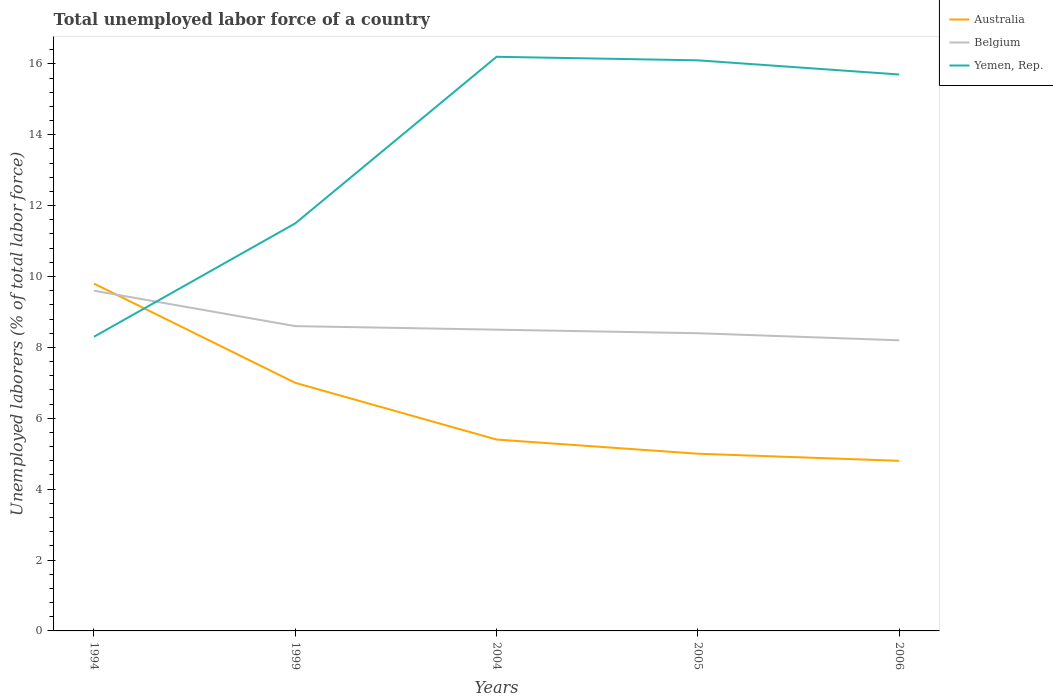How many different coloured lines are there?
Your response must be concise. 3. Does the line corresponding to Australia intersect with the line corresponding to Yemen, Rep.?
Offer a terse response. Yes. Is the number of lines equal to the number of legend labels?
Make the answer very short. Yes. Across all years, what is the maximum total unemployed labor force in Belgium?
Offer a very short reply. 8.2. What is the total total unemployed labor force in Yemen, Rep. in the graph?
Your answer should be very brief. -4.6. What is the difference between the highest and the second highest total unemployed labor force in Belgium?
Your answer should be compact. 1.4. What is the difference between the highest and the lowest total unemployed labor force in Australia?
Offer a terse response. 2. Is the total unemployed labor force in Australia strictly greater than the total unemployed labor force in Yemen, Rep. over the years?
Ensure brevity in your answer.  No. What is the difference between two consecutive major ticks on the Y-axis?
Offer a very short reply. 2. Are the values on the major ticks of Y-axis written in scientific E-notation?
Provide a succinct answer. No. Where does the legend appear in the graph?
Your response must be concise. Top right. How many legend labels are there?
Your response must be concise. 3. How are the legend labels stacked?
Keep it short and to the point. Vertical. What is the title of the graph?
Make the answer very short. Total unemployed labor force of a country. What is the label or title of the Y-axis?
Make the answer very short. Unemployed laborers (% of total labor force). What is the Unemployed laborers (% of total labor force) of Australia in 1994?
Your response must be concise. 9.8. What is the Unemployed laborers (% of total labor force) of Belgium in 1994?
Provide a succinct answer. 9.6. What is the Unemployed laborers (% of total labor force) of Yemen, Rep. in 1994?
Offer a terse response. 8.3. What is the Unemployed laborers (% of total labor force) in Belgium in 1999?
Your answer should be very brief. 8.6. What is the Unemployed laborers (% of total labor force) in Australia in 2004?
Provide a succinct answer. 5.4. What is the Unemployed laborers (% of total labor force) in Belgium in 2004?
Provide a succinct answer. 8.5. What is the Unemployed laborers (% of total labor force) of Yemen, Rep. in 2004?
Provide a short and direct response. 16.2. What is the Unemployed laborers (% of total labor force) in Australia in 2005?
Keep it short and to the point. 5. What is the Unemployed laborers (% of total labor force) in Belgium in 2005?
Keep it short and to the point. 8.4. What is the Unemployed laborers (% of total labor force) of Yemen, Rep. in 2005?
Offer a terse response. 16.1. What is the Unemployed laborers (% of total labor force) in Australia in 2006?
Make the answer very short. 4.8. What is the Unemployed laborers (% of total labor force) in Belgium in 2006?
Give a very brief answer. 8.2. What is the Unemployed laborers (% of total labor force) of Yemen, Rep. in 2006?
Provide a short and direct response. 15.7. Across all years, what is the maximum Unemployed laborers (% of total labor force) in Australia?
Offer a terse response. 9.8. Across all years, what is the maximum Unemployed laborers (% of total labor force) of Belgium?
Provide a short and direct response. 9.6. Across all years, what is the maximum Unemployed laborers (% of total labor force) of Yemen, Rep.?
Provide a short and direct response. 16.2. Across all years, what is the minimum Unemployed laborers (% of total labor force) of Australia?
Offer a very short reply. 4.8. Across all years, what is the minimum Unemployed laborers (% of total labor force) in Belgium?
Give a very brief answer. 8.2. Across all years, what is the minimum Unemployed laborers (% of total labor force) of Yemen, Rep.?
Ensure brevity in your answer.  8.3. What is the total Unemployed laborers (% of total labor force) in Belgium in the graph?
Provide a succinct answer. 43.3. What is the total Unemployed laborers (% of total labor force) of Yemen, Rep. in the graph?
Provide a short and direct response. 67.8. What is the difference between the Unemployed laborers (% of total labor force) in Yemen, Rep. in 1994 and that in 1999?
Your response must be concise. -3.2. What is the difference between the Unemployed laborers (% of total labor force) in Australia in 1994 and that in 2004?
Your answer should be very brief. 4.4. What is the difference between the Unemployed laborers (% of total labor force) of Belgium in 1994 and that in 2004?
Provide a succinct answer. 1.1. What is the difference between the Unemployed laborers (% of total labor force) in Belgium in 1994 and that in 2005?
Make the answer very short. 1.2. What is the difference between the Unemployed laborers (% of total labor force) of Yemen, Rep. in 1994 and that in 2005?
Keep it short and to the point. -7.8. What is the difference between the Unemployed laborers (% of total labor force) in Australia in 1994 and that in 2006?
Make the answer very short. 5. What is the difference between the Unemployed laborers (% of total labor force) of Yemen, Rep. in 1994 and that in 2006?
Offer a terse response. -7.4. What is the difference between the Unemployed laborers (% of total labor force) in Belgium in 1999 and that in 2004?
Offer a terse response. 0.1. What is the difference between the Unemployed laborers (% of total labor force) in Yemen, Rep. in 1999 and that in 2004?
Provide a succinct answer. -4.7. What is the difference between the Unemployed laborers (% of total labor force) of Australia in 1999 and that in 2005?
Give a very brief answer. 2. What is the difference between the Unemployed laborers (% of total labor force) in Australia in 1999 and that in 2006?
Your response must be concise. 2.2. What is the difference between the Unemployed laborers (% of total labor force) of Belgium in 1999 and that in 2006?
Provide a short and direct response. 0.4. What is the difference between the Unemployed laborers (% of total labor force) of Yemen, Rep. in 1999 and that in 2006?
Make the answer very short. -4.2. What is the difference between the Unemployed laborers (% of total labor force) of Australia in 2004 and that in 2005?
Give a very brief answer. 0.4. What is the difference between the Unemployed laborers (% of total labor force) in Yemen, Rep. in 2004 and that in 2005?
Make the answer very short. 0.1. What is the difference between the Unemployed laborers (% of total labor force) in Belgium in 2005 and that in 2006?
Make the answer very short. 0.2. What is the difference between the Unemployed laborers (% of total labor force) of Yemen, Rep. in 2005 and that in 2006?
Provide a short and direct response. 0.4. What is the difference between the Unemployed laborers (% of total labor force) of Belgium in 1994 and the Unemployed laborers (% of total labor force) of Yemen, Rep. in 1999?
Provide a short and direct response. -1.9. What is the difference between the Unemployed laborers (% of total labor force) in Australia in 1994 and the Unemployed laborers (% of total labor force) in Belgium in 2004?
Make the answer very short. 1.3. What is the difference between the Unemployed laborers (% of total labor force) of Australia in 1994 and the Unemployed laborers (% of total labor force) of Belgium in 2005?
Provide a succinct answer. 1.4. What is the difference between the Unemployed laborers (% of total labor force) of Belgium in 1994 and the Unemployed laborers (% of total labor force) of Yemen, Rep. in 2005?
Provide a short and direct response. -6.5. What is the difference between the Unemployed laborers (% of total labor force) in Australia in 1999 and the Unemployed laborers (% of total labor force) in Yemen, Rep. in 2004?
Keep it short and to the point. -9.2. What is the difference between the Unemployed laborers (% of total labor force) of Belgium in 1999 and the Unemployed laborers (% of total labor force) of Yemen, Rep. in 2004?
Offer a very short reply. -7.6. What is the difference between the Unemployed laborers (% of total labor force) of Australia in 1999 and the Unemployed laborers (% of total labor force) of Yemen, Rep. in 2005?
Your answer should be compact. -9.1. What is the difference between the Unemployed laborers (% of total labor force) of Belgium in 1999 and the Unemployed laborers (% of total labor force) of Yemen, Rep. in 2005?
Offer a very short reply. -7.5. What is the difference between the Unemployed laborers (% of total labor force) of Australia in 1999 and the Unemployed laborers (% of total labor force) of Belgium in 2006?
Provide a short and direct response. -1.2. What is the difference between the Unemployed laborers (% of total labor force) in Belgium in 1999 and the Unemployed laborers (% of total labor force) in Yemen, Rep. in 2006?
Your response must be concise. -7.1. What is the difference between the Unemployed laborers (% of total labor force) in Australia in 2004 and the Unemployed laborers (% of total labor force) in Yemen, Rep. in 2005?
Keep it short and to the point. -10.7. What is the difference between the Unemployed laborers (% of total labor force) of Australia in 2004 and the Unemployed laborers (% of total labor force) of Yemen, Rep. in 2006?
Give a very brief answer. -10.3. What is the difference between the Unemployed laborers (% of total labor force) in Belgium in 2004 and the Unemployed laborers (% of total labor force) in Yemen, Rep. in 2006?
Your answer should be very brief. -7.2. What is the difference between the Unemployed laborers (% of total labor force) of Australia in 2005 and the Unemployed laborers (% of total labor force) of Yemen, Rep. in 2006?
Provide a short and direct response. -10.7. What is the average Unemployed laborers (% of total labor force) of Belgium per year?
Keep it short and to the point. 8.66. What is the average Unemployed laborers (% of total labor force) of Yemen, Rep. per year?
Offer a terse response. 13.56. In the year 1999, what is the difference between the Unemployed laborers (% of total labor force) of Australia and Unemployed laborers (% of total labor force) of Belgium?
Make the answer very short. -1.6. In the year 1999, what is the difference between the Unemployed laborers (% of total labor force) in Australia and Unemployed laborers (% of total labor force) in Yemen, Rep.?
Offer a terse response. -4.5. In the year 1999, what is the difference between the Unemployed laborers (% of total labor force) in Belgium and Unemployed laborers (% of total labor force) in Yemen, Rep.?
Provide a short and direct response. -2.9. In the year 2005, what is the difference between the Unemployed laborers (% of total labor force) of Australia and Unemployed laborers (% of total labor force) of Belgium?
Offer a very short reply. -3.4. In the year 2005, what is the difference between the Unemployed laborers (% of total labor force) in Belgium and Unemployed laborers (% of total labor force) in Yemen, Rep.?
Provide a succinct answer. -7.7. In the year 2006, what is the difference between the Unemployed laborers (% of total labor force) in Australia and Unemployed laborers (% of total labor force) in Belgium?
Keep it short and to the point. -3.4. What is the ratio of the Unemployed laborers (% of total labor force) of Belgium in 1994 to that in 1999?
Your response must be concise. 1.12. What is the ratio of the Unemployed laborers (% of total labor force) of Yemen, Rep. in 1994 to that in 1999?
Ensure brevity in your answer.  0.72. What is the ratio of the Unemployed laborers (% of total labor force) of Australia in 1994 to that in 2004?
Offer a very short reply. 1.81. What is the ratio of the Unemployed laborers (% of total labor force) of Belgium in 1994 to that in 2004?
Keep it short and to the point. 1.13. What is the ratio of the Unemployed laborers (% of total labor force) of Yemen, Rep. in 1994 to that in 2004?
Make the answer very short. 0.51. What is the ratio of the Unemployed laborers (% of total labor force) in Australia in 1994 to that in 2005?
Your answer should be compact. 1.96. What is the ratio of the Unemployed laborers (% of total labor force) of Belgium in 1994 to that in 2005?
Give a very brief answer. 1.14. What is the ratio of the Unemployed laborers (% of total labor force) in Yemen, Rep. in 1994 to that in 2005?
Your answer should be very brief. 0.52. What is the ratio of the Unemployed laborers (% of total labor force) of Australia in 1994 to that in 2006?
Provide a succinct answer. 2.04. What is the ratio of the Unemployed laborers (% of total labor force) of Belgium in 1994 to that in 2006?
Ensure brevity in your answer.  1.17. What is the ratio of the Unemployed laborers (% of total labor force) of Yemen, Rep. in 1994 to that in 2006?
Provide a short and direct response. 0.53. What is the ratio of the Unemployed laborers (% of total labor force) in Australia in 1999 to that in 2004?
Your response must be concise. 1.3. What is the ratio of the Unemployed laborers (% of total labor force) of Belgium in 1999 to that in 2004?
Give a very brief answer. 1.01. What is the ratio of the Unemployed laborers (% of total labor force) of Yemen, Rep. in 1999 to that in 2004?
Your answer should be very brief. 0.71. What is the ratio of the Unemployed laborers (% of total labor force) in Belgium in 1999 to that in 2005?
Make the answer very short. 1.02. What is the ratio of the Unemployed laborers (% of total labor force) of Yemen, Rep. in 1999 to that in 2005?
Offer a terse response. 0.71. What is the ratio of the Unemployed laborers (% of total labor force) in Australia in 1999 to that in 2006?
Your response must be concise. 1.46. What is the ratio of the Unemployed laborers (% of total labor force) in Belgium in 1999 to that in 2006?
Your response must be concise. 1.05. What is the ratio of the Unemployed laborers (% of total labor force) of Yemen, Rep. in 1999 to that in 2006?
Give a very brief answer. 0.73. What is the ratio of the Unemployed laborers (% of total labor force) in Australia in 2004 to that in 2005?
Make the answer very short. 1.08. What is the ratio of the Unemployed laborers (% of total labor force) of Belgium in 2004 to that in 2005?
Keep it short and to the point. 1.01. What is the ratio of the Unemployed laborers (% of total labor force) of Belgium in 2004 to that in 2006?
Your response must be concise. 1.04. What is the ratio of the Unemployed laborers (% of total labor force) in Yemen, Rep. in 2004 to that in 2006?
Keep it short and to the point. 1.03. What is the ratio of the Unemployed laborers (% of total labor force) of Australia in 2005 to that in 2006?
Ensure brevity in your answer.  1.04. What is the ratio of the Unemployed laborers (% of total labor force) of Belgium in 2005 to that in 2006?
Offer a terse response. 1.02. What is the ratio of the Unemployed laborers (% of total labor force) of Yemen, Rep. in 2005 to that in 2006?
Provide a short and direct response. 1.03. What is the difference between the highest and the second highest Unemployed laborers (% of total labor force) in Australia?
Make the answer very short. 2.8. What is the difference between the highest and the second highest Unemployed laborers (% of total labor force) of Belgium?
Provide a succinct answer. 1. What is the difference between the highest and the second highest Unemployed laborers (% of total labor force) in Yemen, Rep.?
Provide a succinct answer. 0.1. What is the difference between the highest and the lowest Unemployed laborers (% of total labor force) of Australia?
Ensure brevity in your answer.  5. 